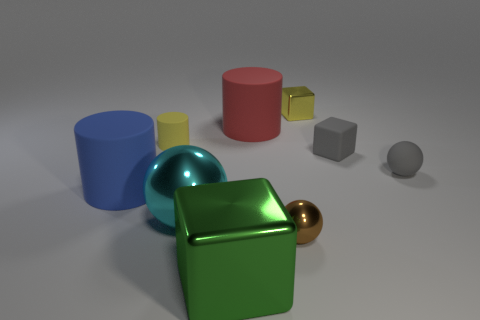The small matte cylinder has what color?
Ensure brevity in your answer.  Yellow. There is a cube that is on the left side of the rubber cylinder that is to the right of the small object that is to the left of the tiny brown ball; what size is it?
Give a very brief answer. Large. What number of other things are there of the same shape as the big cyan thing?
Provide a short and direct response. 2. There is a small thing that is both in front of the tiny metal cube and behind the gray matte cube; what color is it?
Your answer should be compact. Yellow. Is there any other thing that is the same size as the brown ball?
Provide a short and direct response. Yes. Do the small sphere that is right of the tiny metal sphere and the large block have the same color?
Your answer should be very brief. No. What number of cylinders are big purple matte things or big matte objects?
Your answer should be very brief. 2. What is the shape of the tiny gray rubber object left of the tiny gray matte ball?
Your answer should be compact. Cube. The tiny sphere in front of the big cylinder that is on the left side of the metal cube that is in front of the tiny metal sphere is what color?
Your answer should be very brief. Brown. Do the gray sphere and the tiny brown thing have the same material?
Keep it short and to the point. No. 